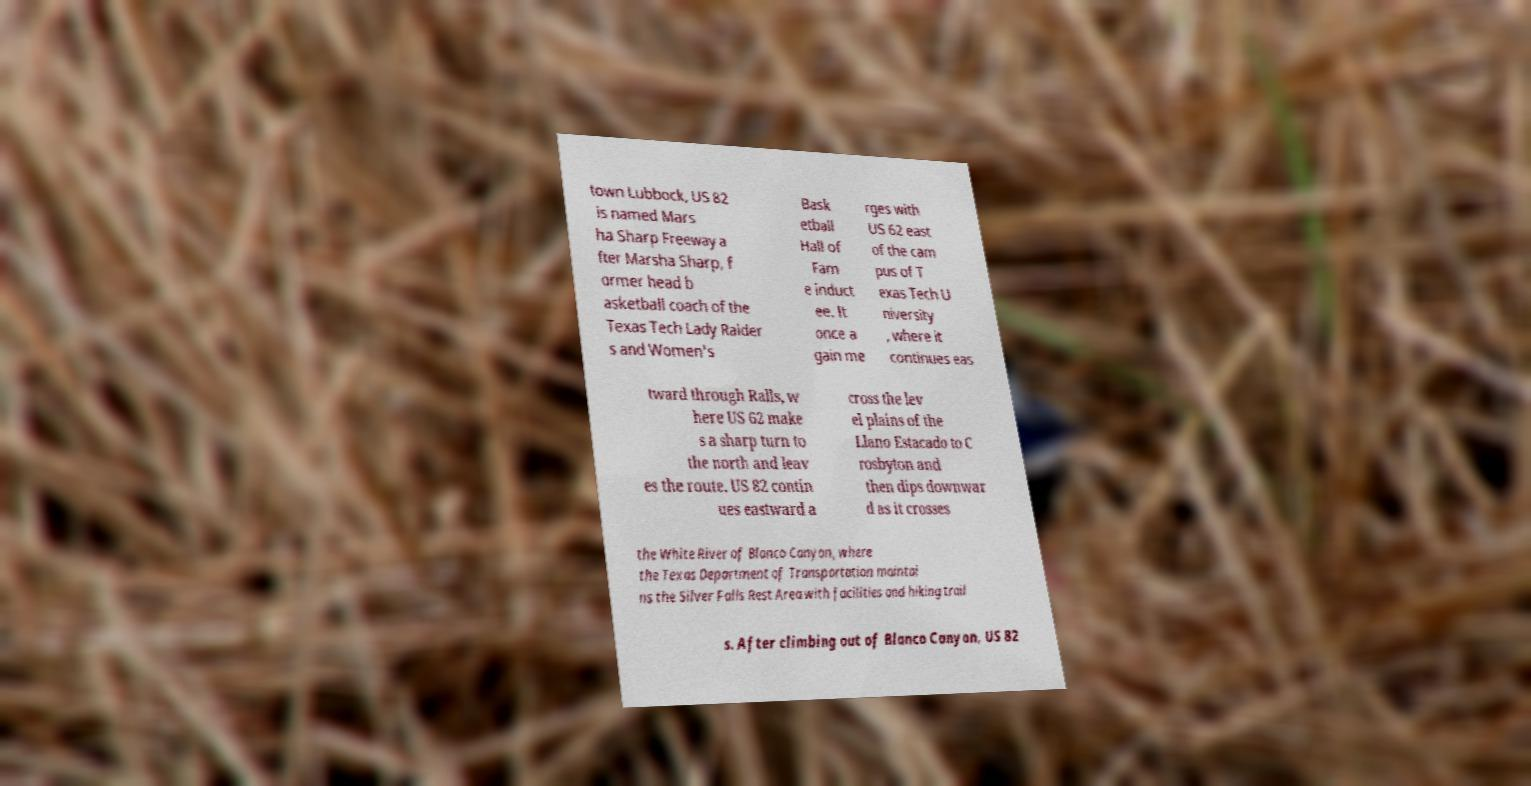Can you accurately transcribe the text from the provided image for me? town Lubbock, US 82 is named Mars ha Sharp Freeway a fter Marsha Sharp, f ormer head b asketball coach of the Texas Tech Lady Raider s and Women's Bask etball Hall of Fam e induct ee. It once a gain me rges with US 62 east of the cam pus of T exas Tech U niversity , where it continues eas tward through Ralls, w here US 62 make s a sharp turn to the north and leav es the route. US 82 contin ues eastward a cross the lev el plains of the Llano Estacado to C rosbyton and then dips downwar d as it crosses the White River of Blanco Canyon, where the Texas Department of Transportation maintai ns the Silver Falls Rest Area with facilities and hiking trail s. After climbing out of Blanco Canyon, US 82 